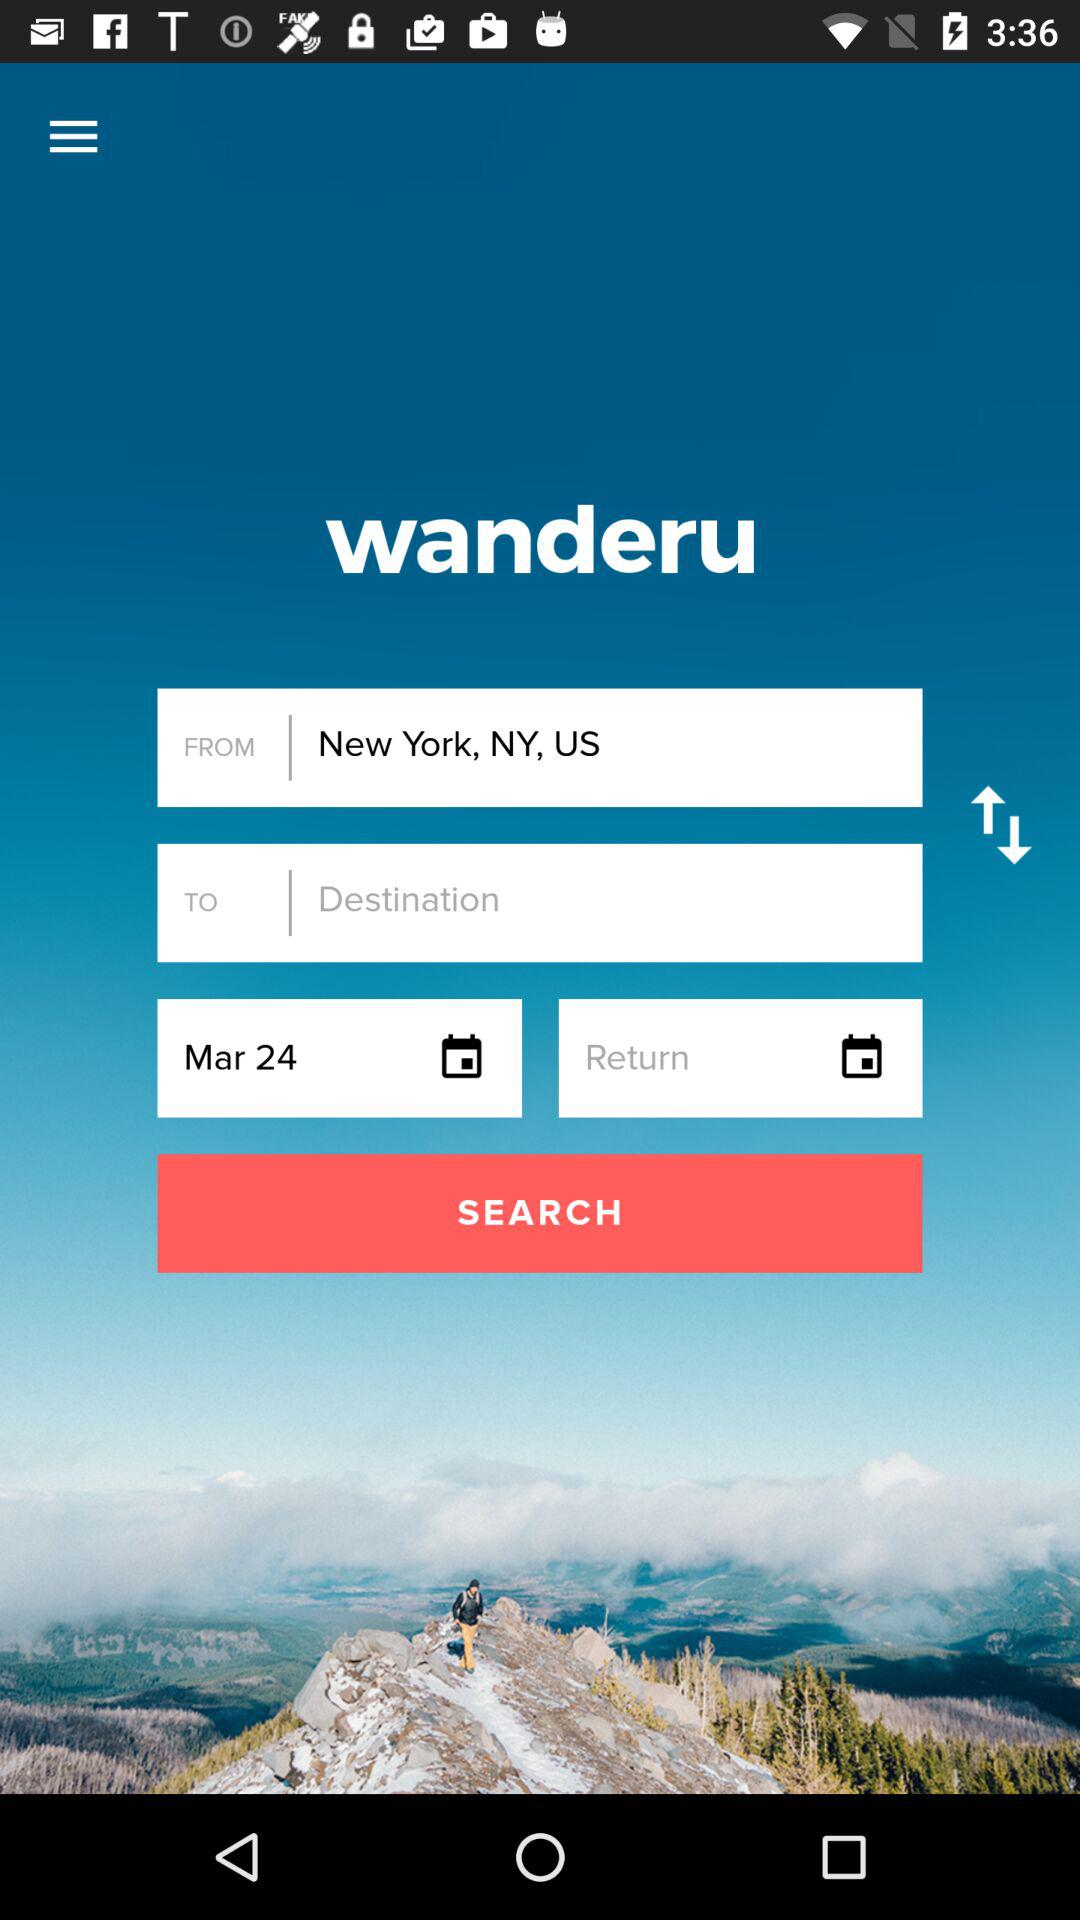Which date is selected from the calendar? The selected date is March 24. 